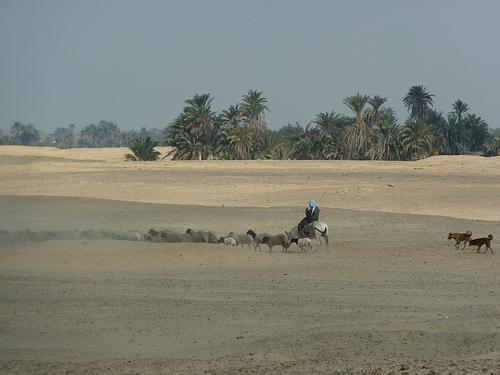How many dogs are there?
Give a very brief answer. 2. 